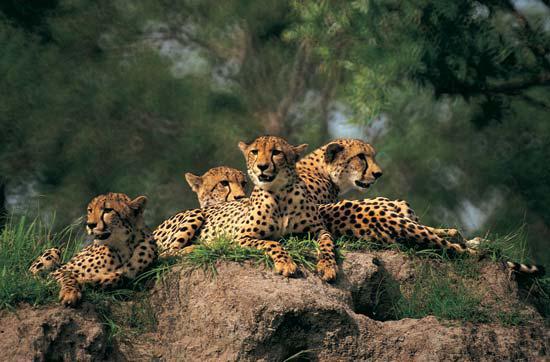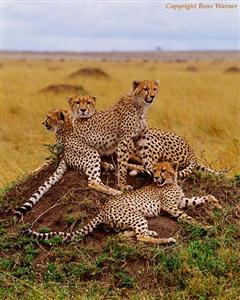The first image is the image on the left, the second image is the image on the right. Examine the images to the left and right. Is the description "Multiple spotted wild cats are in action poses in one of the images." accurate? Answer yes or no. No. The first image is the image on the left, the second image is the image on the right. Assess this claim about the two images: "The leopards in one of the images are moving quickly across the field.". Correct or not? Answer yes or no. No. 